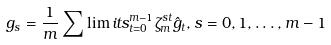<formula> <loc_0><loc_0><loc_500><loc_500>g _ { s } = \frac { 1 } { m } \sum \lim i t s _ { t = 0 } ^ { m - 1 } \zeta _ { m } ^ { s t } \hat { g } _ { t } , s = 0 , 1 , \dots , m - 1</formula> 